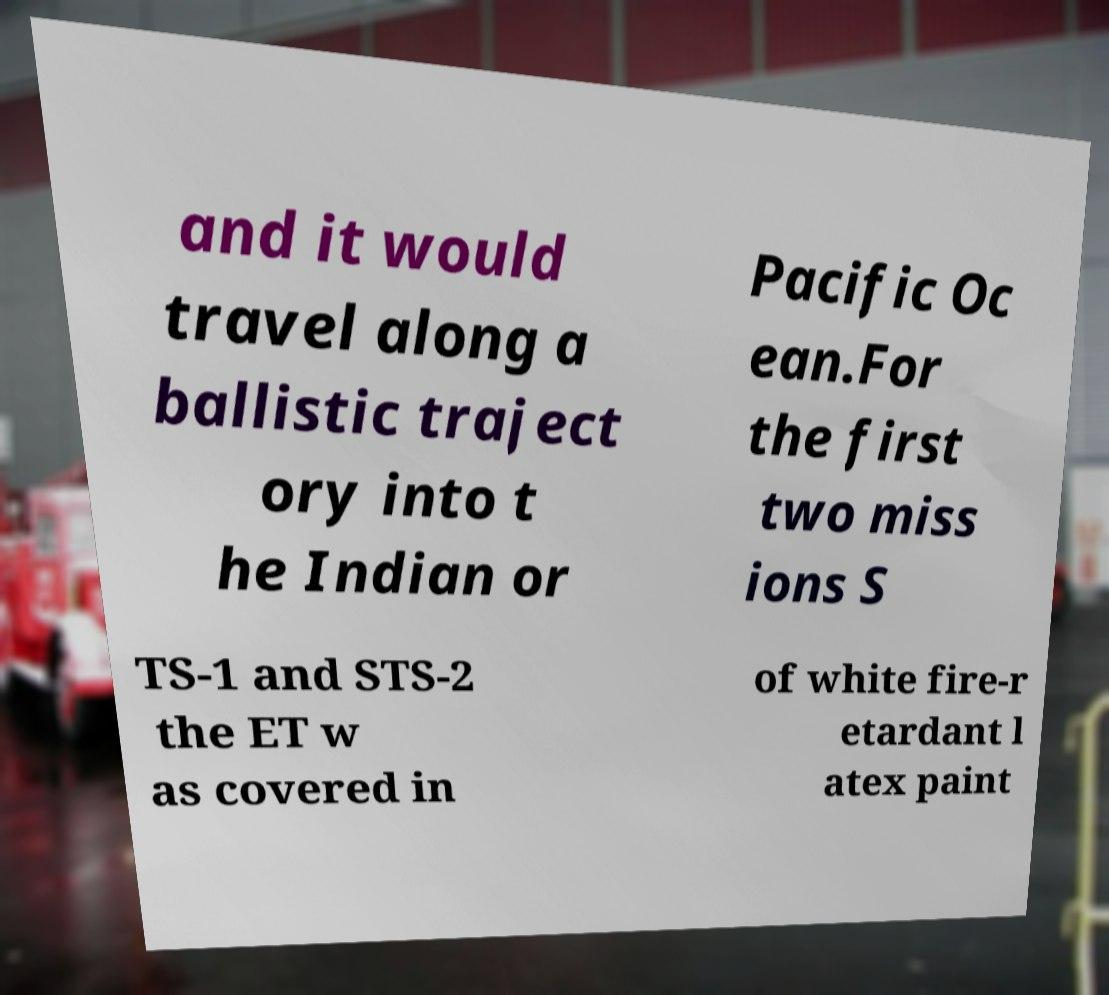Could you extract and type out the text from this image? and it would travel along a ballistic traject ory into t he Indian or Pacific Oc ean.For the first two miss ions S TS-1 and STS-2 the ET w as covered in of white fire-r etardant l atex paint 